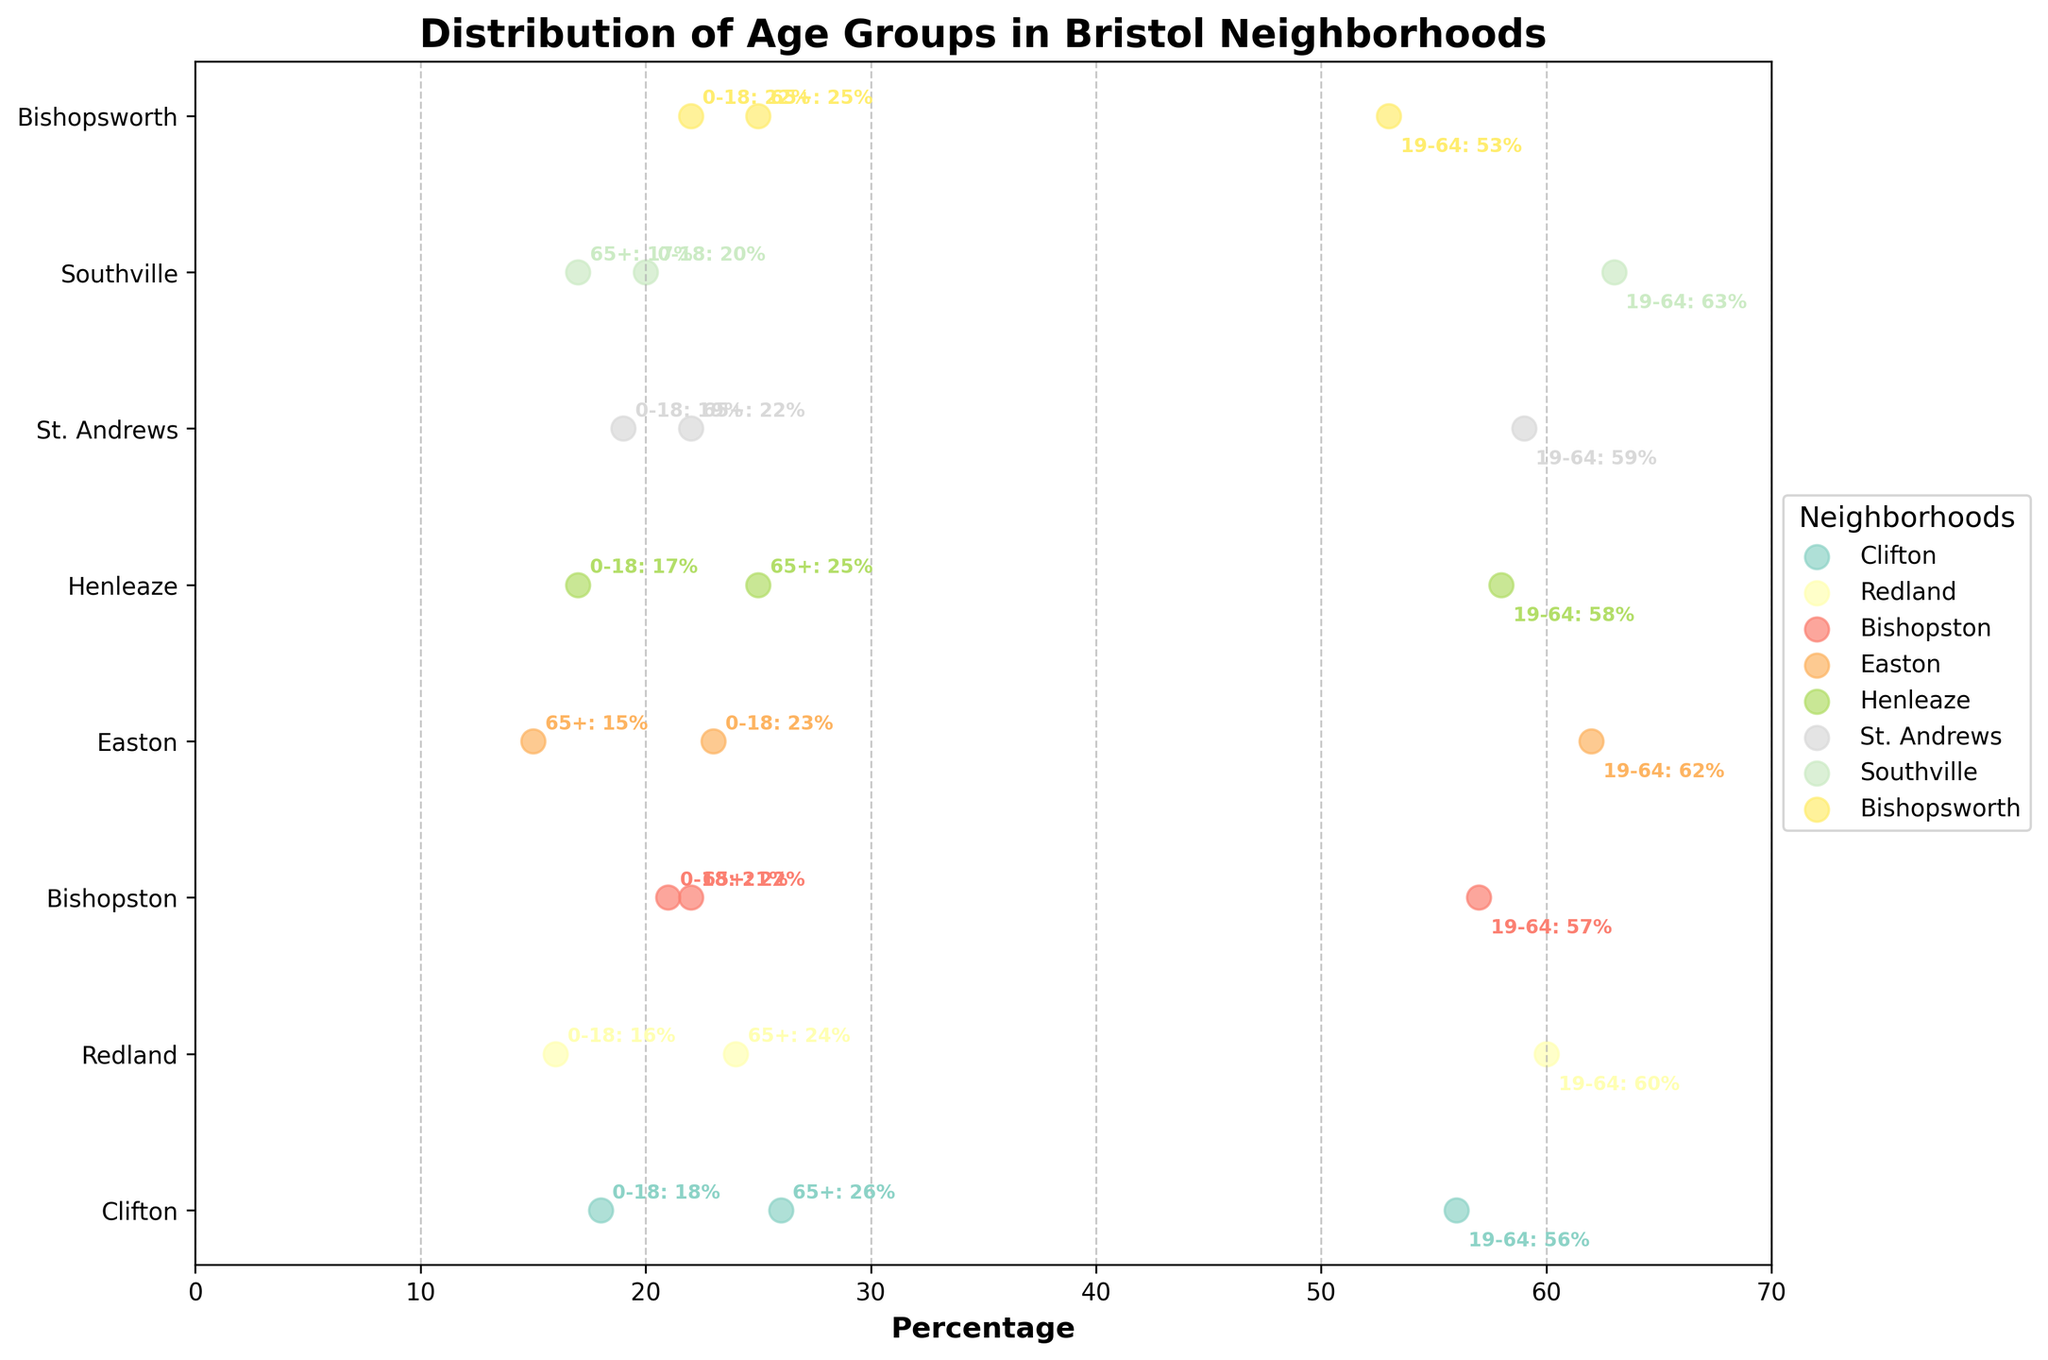What is the age group with the highest percentage in Clifton? Looking at the figure, find the dots representing Clifton and identify which age group has the largest scatter value.
Answer: 19-64 How does the percentage of elderly residents in Easton compare with Bishopsworth? Find the 65+ percentages for Easton and Bishopsworth, then compare. Easton has 15% and Bishopsworth has 25%, so Bishopsworth has a higher percentage.
Answer: Bishopsworth has a higher percentage Which neighborhood has the highest percentage of residents aged 19-64? Look at the percentage values for the 19-64 age group across all neighborhoods and identify the highest one. Southville has the highest percentage at 63%.
Answer: Southville What percentage of St. Andrews residents are either children or elderly? Add the percentages for the 0-18 and 65+ age groups in St. Andrews. 19% (0-18) + 22% (65+) = 41%.
Answer: 41% Is the percentage of elderly residents greater in Henleaze than in Redland? Compare the 65+ percentages for Henleaze and Redland. Henleaze has 25% and Redland has 24%, so Henleaze is slightly higher.
Answer: Yes Which neighborhoods have at least 25% of their population in the 65+ age group? Identify neighborhoods with a 65+ percentage of 25% or more. Clifton (26%), Henleaze (25%), and Bishopsworth (25%).
Answer: Clifton, Henleaze, Bishopsworth What is the difference in the percentage of children between Bishopston and Southville? Subtract the 0-18 percentage of Southville from that of Bishopston. 21% (Bishopston) - 20% (Southville) = 1%.
Answer: 1% Across all neighborhoods, what is the average percentage of residents aged 0-18? Calculate the average of the 0-18 percentages for each neighborhood. (18 + 16 + 21 + 23 + 17 + 19 + 20 + 22) / 8 = 19.5%.
Answer: 19.5% Does any neighborhood have a higher percentage of elderly residents than young residents (0-18)? Compare the 65+ and 0-18 percentages for each neighborhood. Clifton (65+: 26%, 0-18: 18%) and Henleaze (65+: 25%, 0-18: 17%) have higher elderly percentages.
Answer: Yes, Clifton and Henleaze 